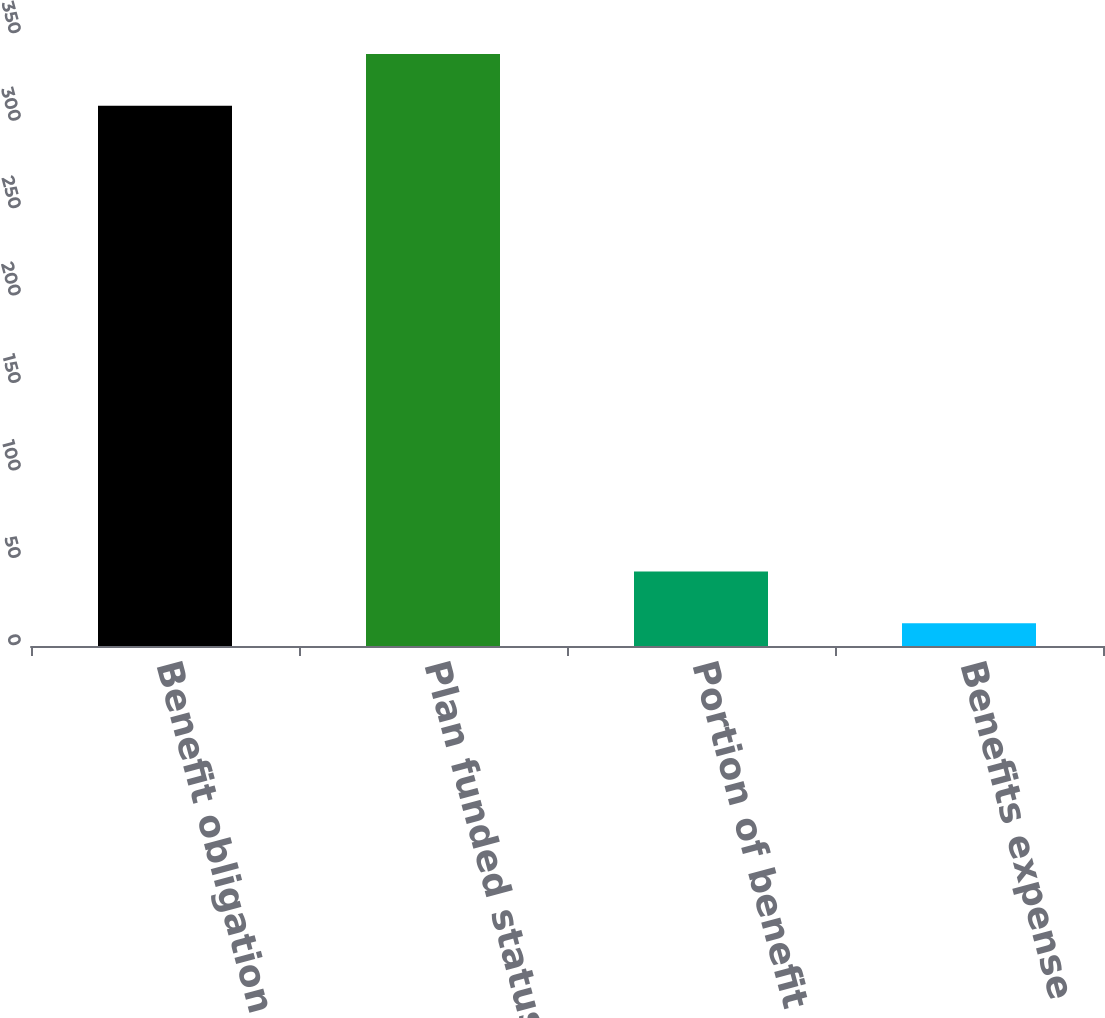Convert chart. <chart><loc_0><loc_0><loc_500><loc_500><bar_chart><fcel>Benefit obligation<fcel>Plan funded status and<fcel>Portion of benefit obligation<fcel>Benefits expense<nl><fcel>309<fcel>338.6<fcel>42.6<fcel>13<nl></chart> 